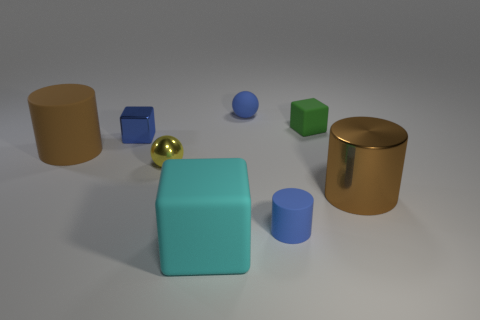How many brown cylinders are behind the green cube?
Keep it short and to the point. 0. Is the material of the tiny blue sphere the same as the brown cylinder left of the blue metallic thing?
Offer a very short reply. Yes. There is a cylinder that is the same material as the yellow sphere; what size is it?
Provide a short and direct response. Large. Is the number of brown things that are behind the small green thing greater than the number of cubes that are to the left of the shiny block?
Keep it short and to the point. No. Is there a tiny green rubber object that has the same shape as the large cyan object?
Provide a short and direct response. Yes. There is a brown object that is left of the green matte cube; is it the same size as the big metallic cylinder?
Your answer should be very brief. Yes. Are any tiny brown shiny spheres visible?
Provide a short and direct response. No. What number of things are metal things that are in front of the tiny blue block or purple rubber cylinders?
Your response must be concise. 2. Do the small matte cylinder and the big cylinder behind the yellow sphere have the same color?
Offer a terse response. No. Is there a blue cube of the same size as the green block?
Offer a terse response. Yes. 